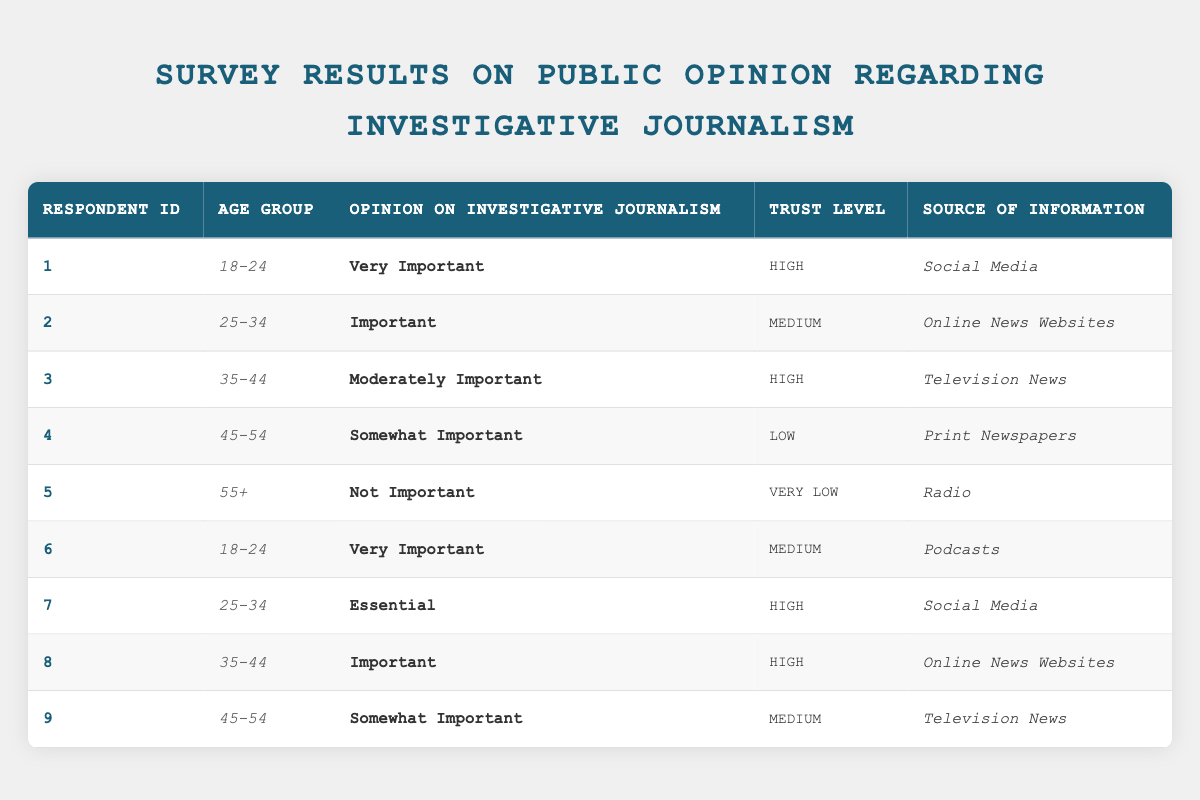What is the opinion of respondents aged 55 and older on investigative journalism? The table shows that one respondent aged 55+ believes investigative journalism is "Not Important."
Answer: Not Important How many respondents rated investigative journalism as "Very Important"? There are two respondents (IDs 1 and 6) who rated investigative journalism as "Very Important."
Answer: 2 Which age group has the highest trust level in investigative journalism? Both the age groups 18-24 and 35-44 have a high trust level, but 25-34, while having important opinions, has a mixture of trust levels, making 18-24 and 35-44 tied for the highest level.
Answer: 18-24 and 35-44 What percentage of respondents aged 25-34 rate investigative journalism as "Essential"? In the 25-34 age group, one out of three respondents rated it as "Essential," which equals approximately 33.33%. Therefore, it's 1 in 3.
Answer: 33.33% Are all sources of information rated equally by age groups? No, the trust levels for various sources differ by age groups; for example, younger respondents tend to trust social media more, while those 45-54 show lower trust in print newspapers.
Answer: No What is the average trust level among respondents who think investigative journalism is "Somewhat Important"? There are 3 respondents who believe that investigative journalism is "Somewhat Important". Their trust levels are Low (1), Medium (2), and Medium (2), with the average being (1+2+2)/3 = 1.67, which is approximately Low.
Answer: Low Which age group has the highest number of total votes for "Important" or above regarding investigative journalism? The 25-34 and 35-44 age groups both have significant votes ("Important" and "Essential"), with two in the younger age group and three in the older group, giving 5 total responses against 6. Thus, the age group of 35-44 has the highest votes for "Important" or above.
Answer: 35-44 What is the trust level of respondents who rely on social media for information? Among those who rely on social media for information, one rated trust as "High" and one as "Medium." So, the trust levels are varied but include both high and medium ratings.
Answer: Mixed levels (High, Medium) Can you compare the source of information of those who find investigative journalism "Very Important" with those who find it "Not Important"? Respondents finding it "Very Important" used Social Media and Podcasts, while the respondent finding it "Not Important" relied on Radio. Thus, the former tend to favor digital and interactive sources against traditional.
Answer: Different sources (Social Media/Podcasts vs Radio) 